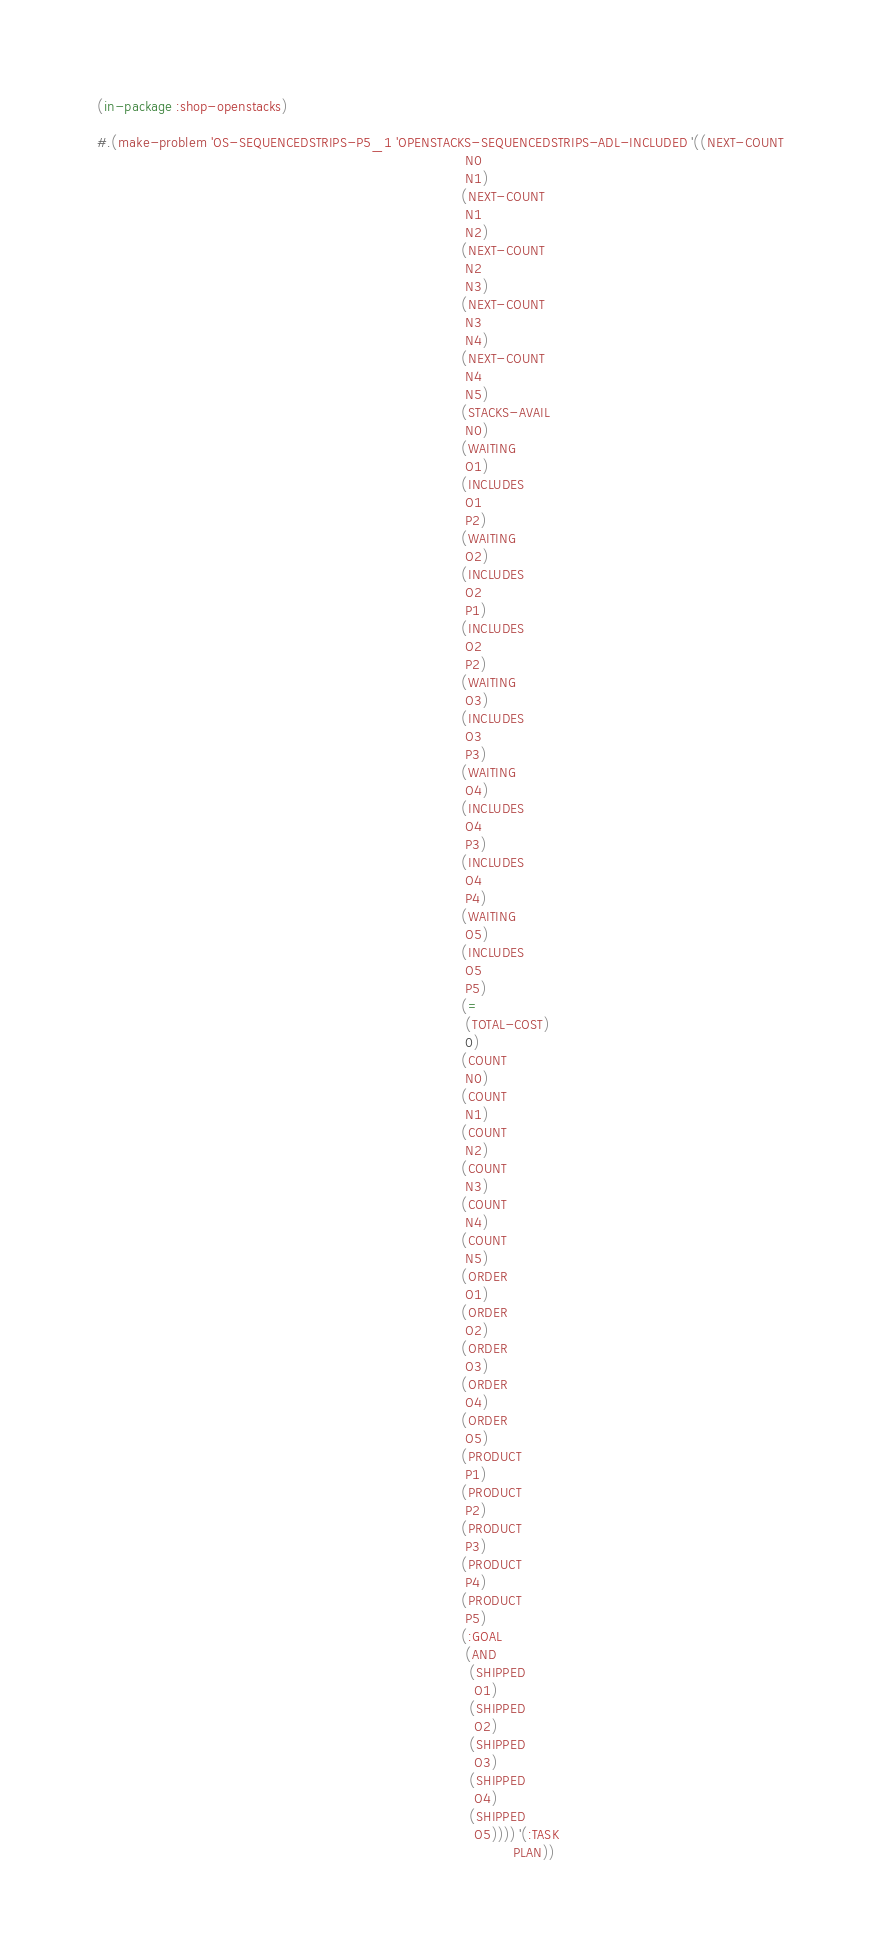<code> <loc_0><loc_0><loc_500><loc_500><_Lisp_>(in-package :shop-openstacks)

#.(make-problem 'OS-SEQUENCEDSTRIPS-P5_1 'OPENSTACKS-SEQUENCEDSTRIPS-ADL-INCLUDED '((NEXT-COUNT
                                                                                     N0
                                                                                     N1)
                                                                                    (NEXT-COUNT
                                                                                     N1
                                                                                     N2)
                                                                                    (NEXT-COUNT
                                                                                     N2
                                                                                     N3)
                                                                                    (NEXT-COUNT
                                                                                     N3
                                                                                     N4)
                                                                                    (NEXT-COUNT
                                                                                     N4
                                                                                     N5)
                                                                                    (STACKS-AVAIL
                                                                                     N0)
                                                                                    (WAITING
                                                                                     O1)
                                                                                    (INCLUDES
                                                                                     O1
                                                                                     P2)
                                                                                    (WAITING
                                                                                     O2)
                                                                                    (INCLUDES
                                                                                     O2
                                                                                     P1)
                                                                                    (INCLUDES
                                                                                     O2
                                                                                     P2)
                                                                                    (WAITING
                                                                                     O3)
                                                                                    (INCLUDES
                                                                                     O3
                                                                                     P3)
                                                                                    (WAITING
                                                                                     O4)
                                                                                    (INCLUDES
                                                                                     O4
                                                                                     P3)
                                                                                    (INCLUDES
                                                                                     O4
                                                                                     P4)
                                                                                    (WAITING
                                                                                     O5)
                                                                                    (INCLUDES
                                                                                     O5
                                                                                     P5)
                                                                                    (=
                                                                                     (TOTAL-COST)
                                                                                     0)
                                                                                    (COUNT
                                                                                     N0)
                                                                                    (COUNT
                                                                                     N1)
                                                                                    (COUNT
                                                                                     N2)
                                                                                    (COUNT
                                                                                     N3)
                                                                                    (COUNT
                                                                                     N4)
                                                                                    (COUNT
                                                                                     N5)
                                                                                    (ORDER
                                                                                     O1)
                                                                                    (ORDER
                                                                                     O2)
                                                                                    (ORDER
                                                                                     O3)
                                                                                    (ORDER
                                                                                     O4)
                                                                                    (ORDER
                                                                                     O5)
                                                                                    (PRODUCT
                                                                                     P1)
                                                                                    (PRODUCT
                                                                                     P2)
                                                                                    (PRODUCT
                                                                                     P3)
                                                                                    (PRODUCT
                                                                                     P4)
                                                                                    (PRODUCT
                                                                                     P5)
                                                                                    (:GOAL
                                                                                     (AND
                                                                                      (SHIPPED
                                                                                       O1)
                                                                                      (SHIPPED
                                                                                       O2)
                                                                                      (SHIPPED
                                                                                       O3)
                                                                                      (SHIPPED
                                                                                       O4)
                                                                                      (SHIPPED
                                                                                       O5)))) '(:TASK
                                                                                                PLAN)) </code> 